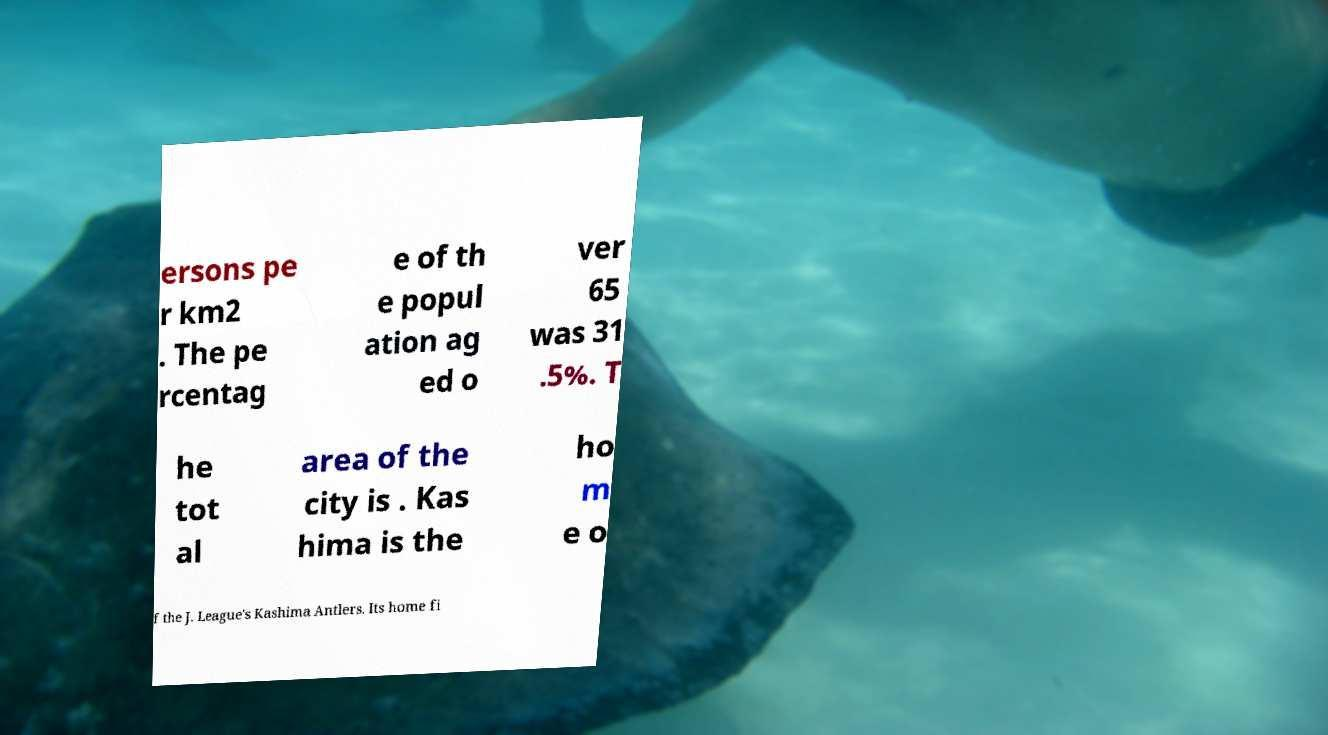What messages or text are displayed in this image? I need them in a readable, typed format. ersons pe r km2 . The pe rcentag e of th e popul ation ag ed o ver 65 was 31 .5%. T he tot al area of the city is . Kas hima is the ho m e o f the J. League's Kashima Antlers. Its home fi 